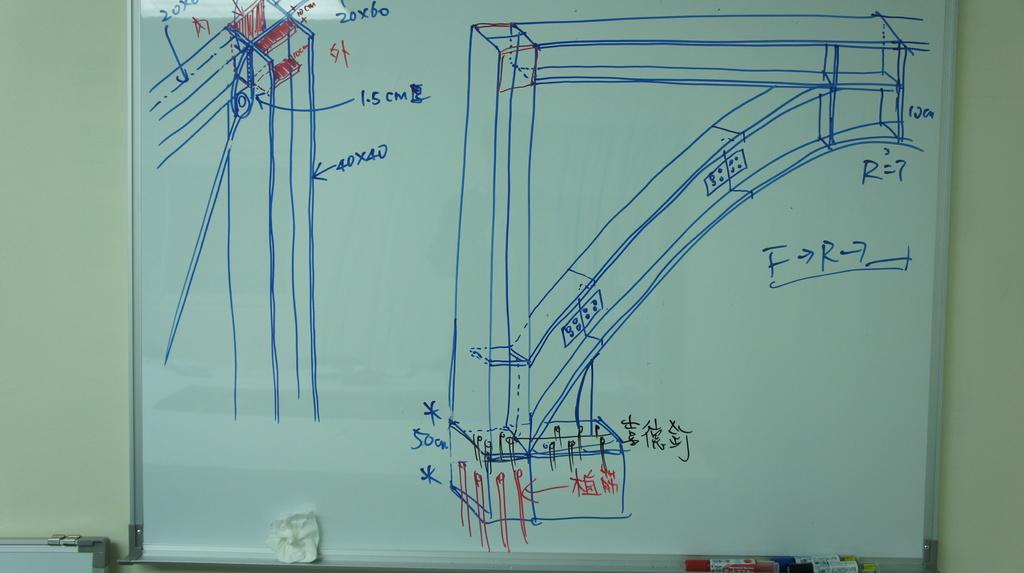<image>
Offer a succinct explanation of the picture presented. A schematic of a support beam is drawn on a whiteboard and says 40X40. 